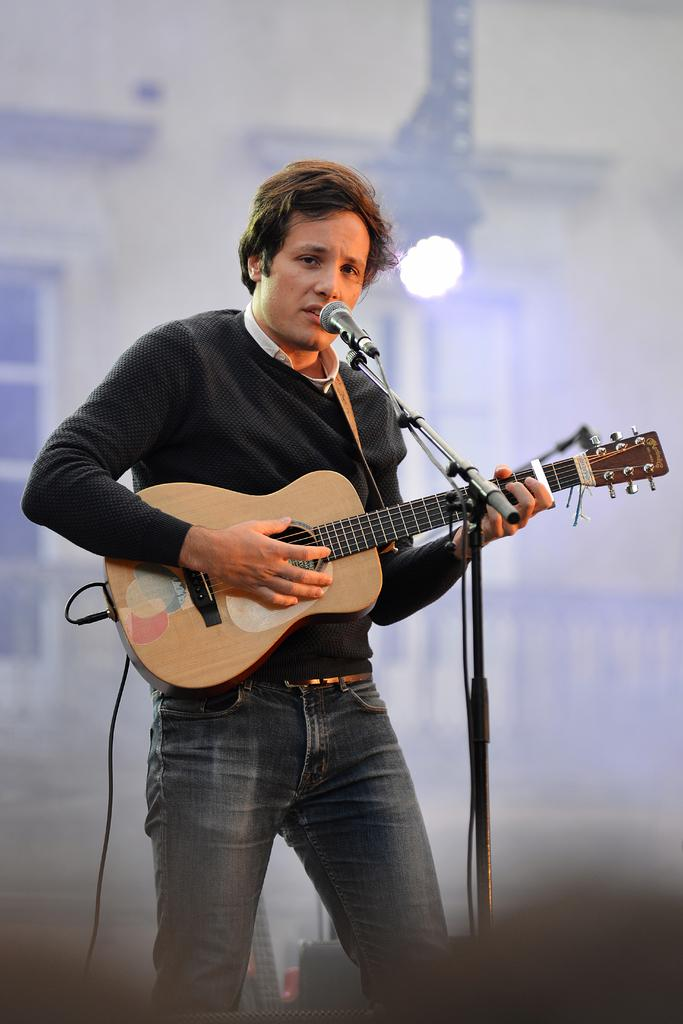What is the main subject of the image? The main subject of the image is a man. What is the man doing in the image? The man is standing and holding a guitar in his hand. What object is in front of the man? There is a microphone with a stand in front of the man. Can you describe the background of the image? The background of the image is blurry. What type of oven can be seen in the background of the image? There is no oven present in the image; the background is blurry. What observation can be made about the man's ability to play the guitar in the image? The image does not show the man playing the guitar, so it cannot be determined if he can play it or not. 